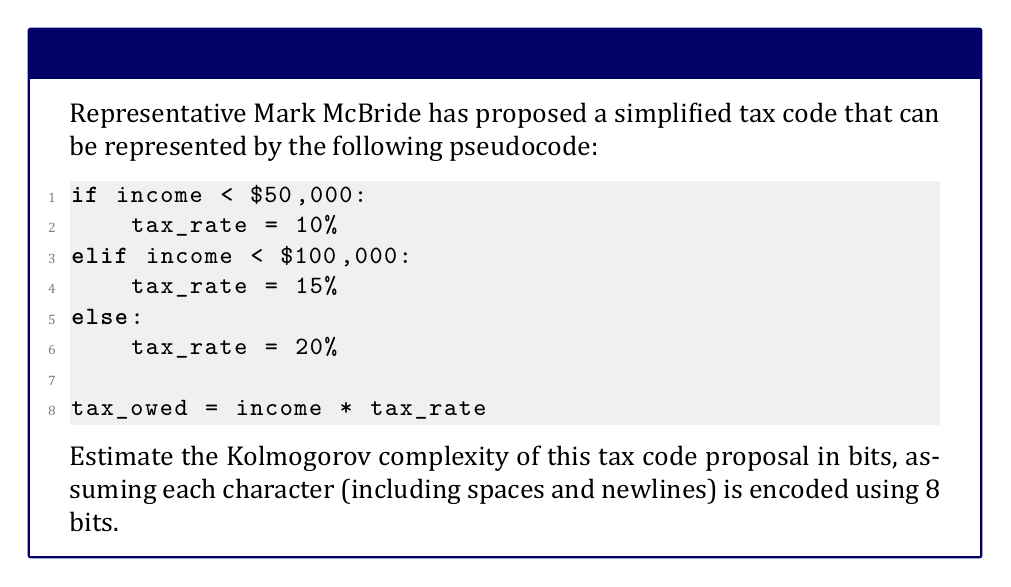Solve this math problem. To estimate the Kolmogorov complexity of the simplified tax code proposal, we need to determine the shortest possible description of the code. In this case, we can use the given pseudocode as a reasonable approximation.

Step 1: Count the number of characters in the pseudocode.
Total characters = 116 (including spaces and newlines)

Step 2: Calculate the number of bits required to represent the code.
Since each character is encoded using 8 bits:

$$\text{Total bits} = \text{Number of characters} \times 8$$
$$\text{Total bits} = 116 \times 8 = 928 \text{ bits}$$

Step 3: Consider potential optimizations.
While there might be ways to compress this code further, such as using shorter variable names or a more compact representation, the given pseudocode is already quite concise. Therefore, we can consider this a reasonable estimate of the Kolmogorov complexity.

The Kolmogorov complexity is defined as the length of the shortest possible description of the object. In this case, our estimate of 928 bits represents a upper bound on the true Kolmogorov complexity, as there might exist shorter descriptions that we haven't considered.
Answer: 928 bits 